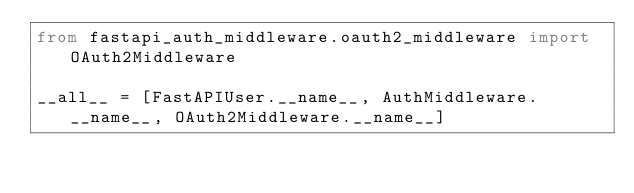Convert code to text. <code><loc_0><loc_0><loc_500><loc_500><_Python_>from fastapi_auth_middleware.oauth2_middleware import OAuth2Middleware

__all__ = [FastAPIUser.__name__, AuthMiddleware.__name__, OAuth2Middleware.__name__]
</code> 